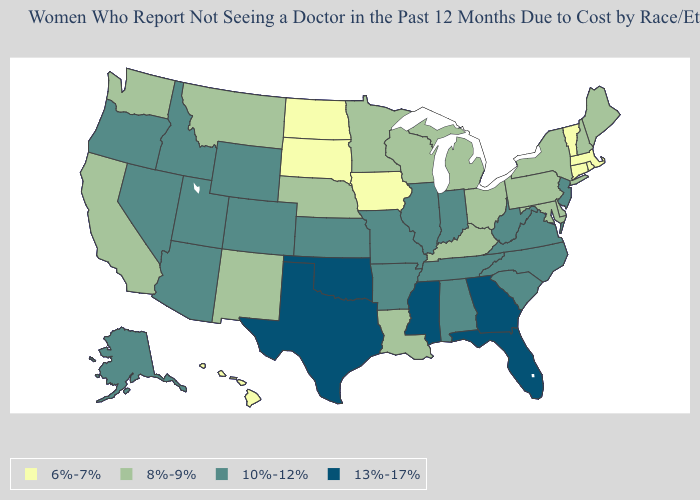Name the states that have a value in the range 13%-17%?
Quick response, please. Florida, Georgia, Mississippi, Oklahoma, Texas. Does Florida have the highest value in the South?
Short answer required. Yes. How many symbols are there in the legend?
Be succinct. 4. Name the states that have a value in the range 10%-12%?
Answer briefly. Alabama, Alaska, Arizona, Arkansas, Colorado, Idaho, Illinois, Indiana, Kansas, Missouri, Nevada, New Jersey, North Carolina, Oregon, South Carolina, Tennessee, Utah, Virginia, West Virginia, Wyoming. What is the value of Michigan?
Answer briefly. 8%-9%. Name the states that have a value in the range 13%-17%?
Short answer required. Florida, Georgia, Mississippi, Oklahoma, Texas. Among the states that border Pennsylvania , which have the highest value?
Answer briefly. New Jersey, West Virginia. Does Alabama have the highest value in the USA?
Quick response, please. No. Name the states that have a value in the range 10%-12%?
Write a very short answer. Alabama, Alaska, Arizona, Arkansas, Colorado, Idaho, Illinois, Indiana, Kansas, Missouri, Nevada, New Jersey, North Carolina, Oregon, South Carolina, Tennessee, Utah, Virginia, West Virginia, Wyoming. Which states hav the highest value in the Northeast?
Be succinct. New Jersey. What is the highest value in the USA?
Keep it brief. 13%-17%. What is the highest value in the West ?
Be succinct. 10%-12%. Does New Jersey have a lower value than Louisiana?
Concise answer only. No. Name the states that have a value in the range 6%-7%?
Give a very brief answer. Connecticut, Hawaii, Iowa, Massachusetts, North Dakota, Rhode Island, South Dakota, Vermont. 